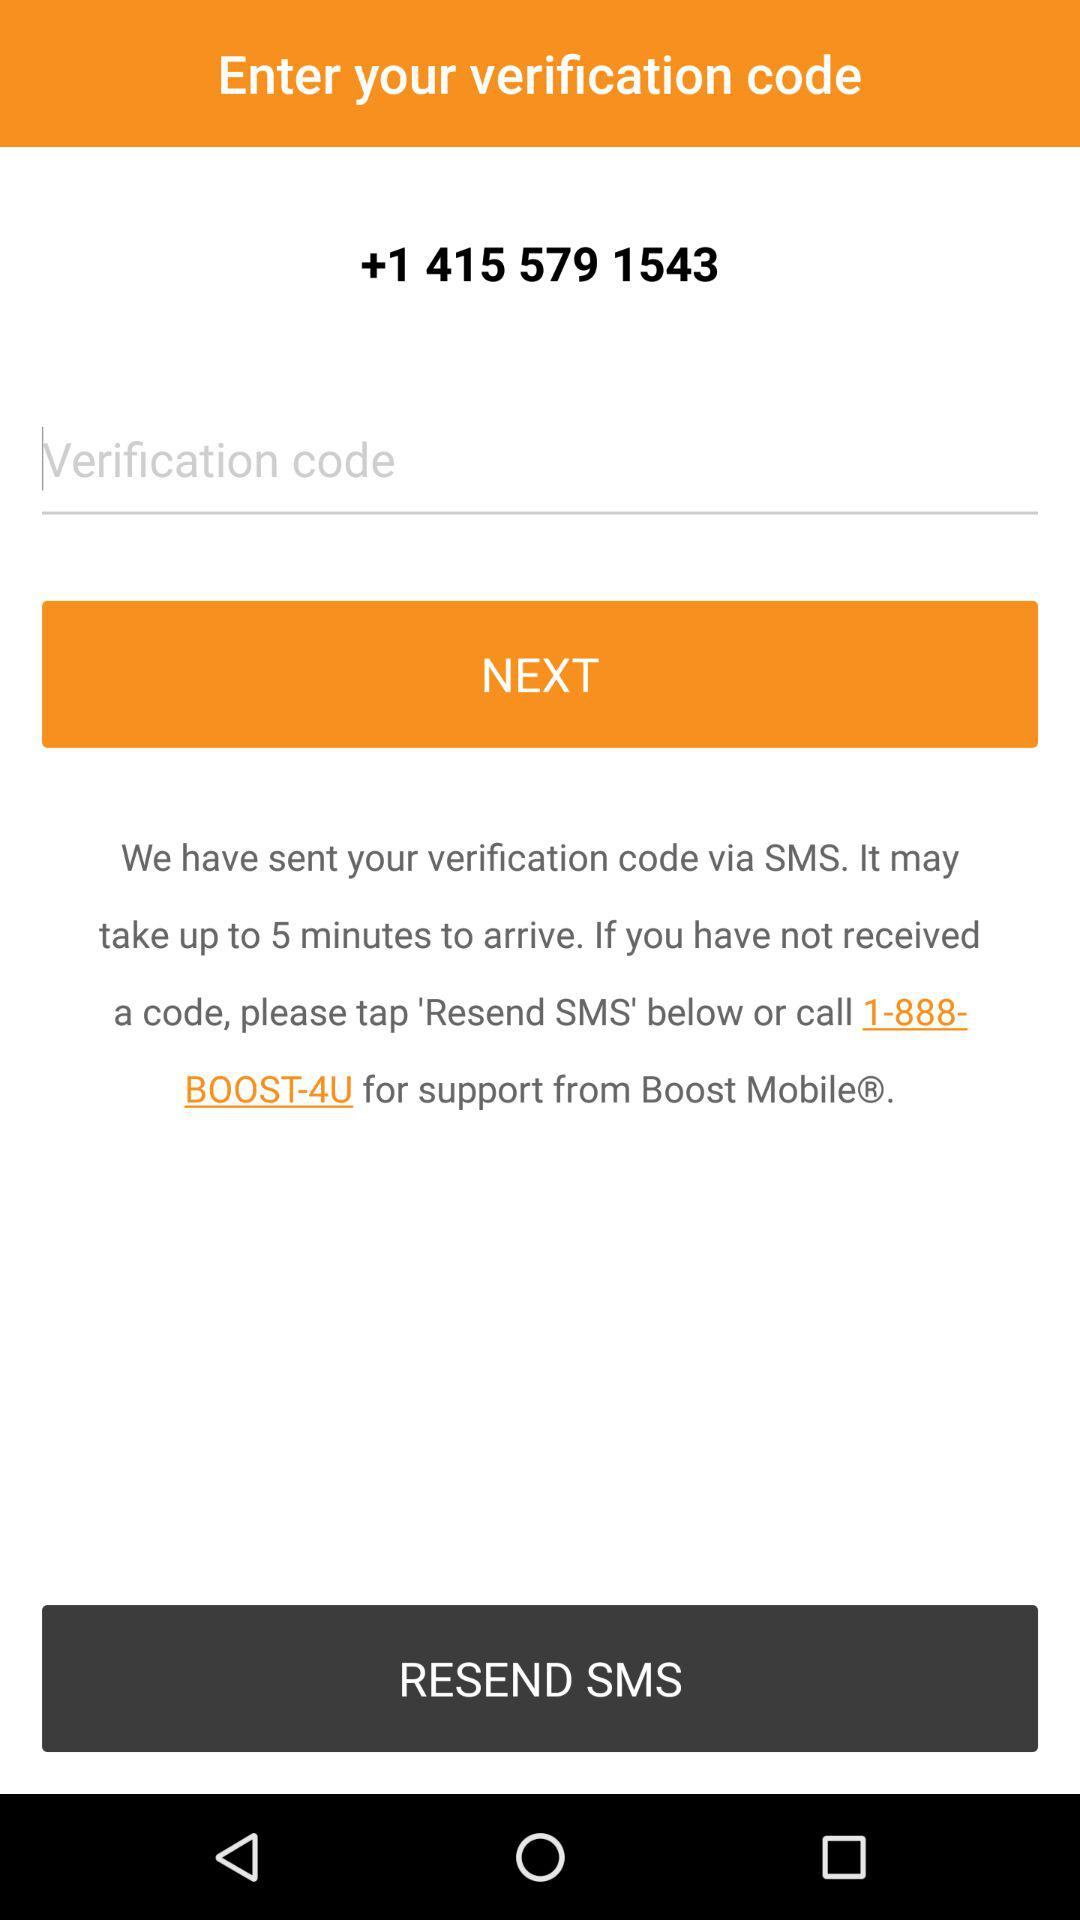How many ways are there to get a verification code?
Answer the question using a single word or phrase. 2 